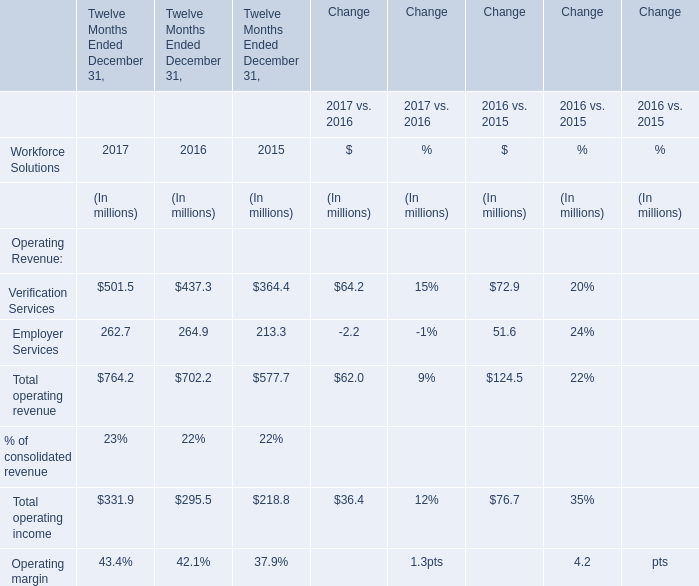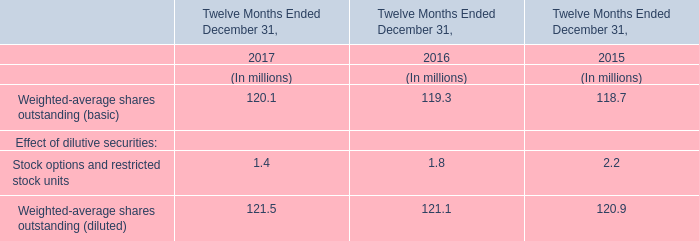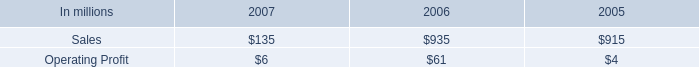what was the ratio of the increase in the cash working capital components in 2007 compared to 2006 
Computations: (539 / 354)
Answer: 1.5226. 